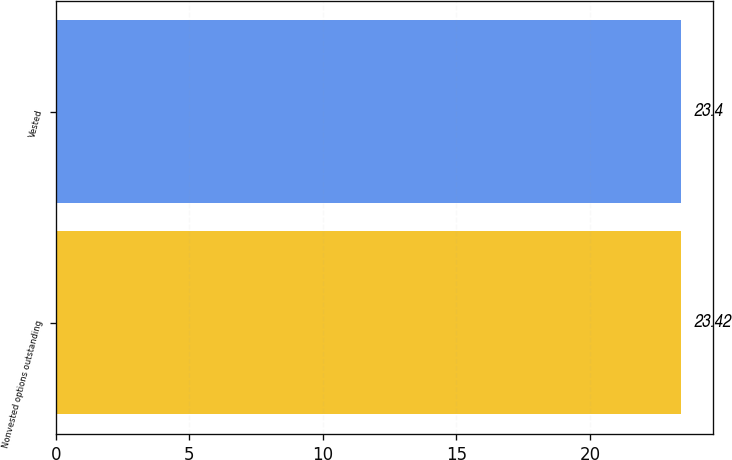<chart> <loc_0><loc_0><loc_500><loc_500><bar_chart><fcel>Nonvested options outstanding<fcel>Vested<nl><fcel>23.42<fcel>23.4<nl></chart> 